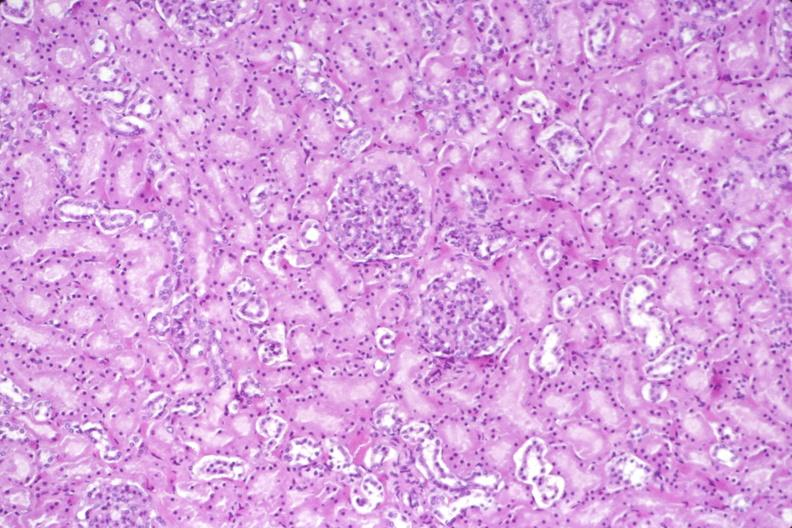does this image show kidney, normal histology?
Answer the question using a single word or phrase. Yes 